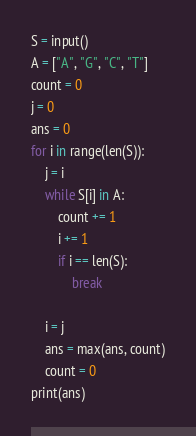Convert code to text. <code><loc_0><loc_0><loc_500><loc_500><_Python_>S = input()
A = ["A", "G", "C", "T"]
count = 0
j = 0
ans = 0
for i in range(len(S)):
    j = i
    while S[i] in A:
        count += 1
        i += 1
        if i == len(S):
            break

    i = j
    ans = max(ans, count)
    count = 0
print(ans)



</code> 